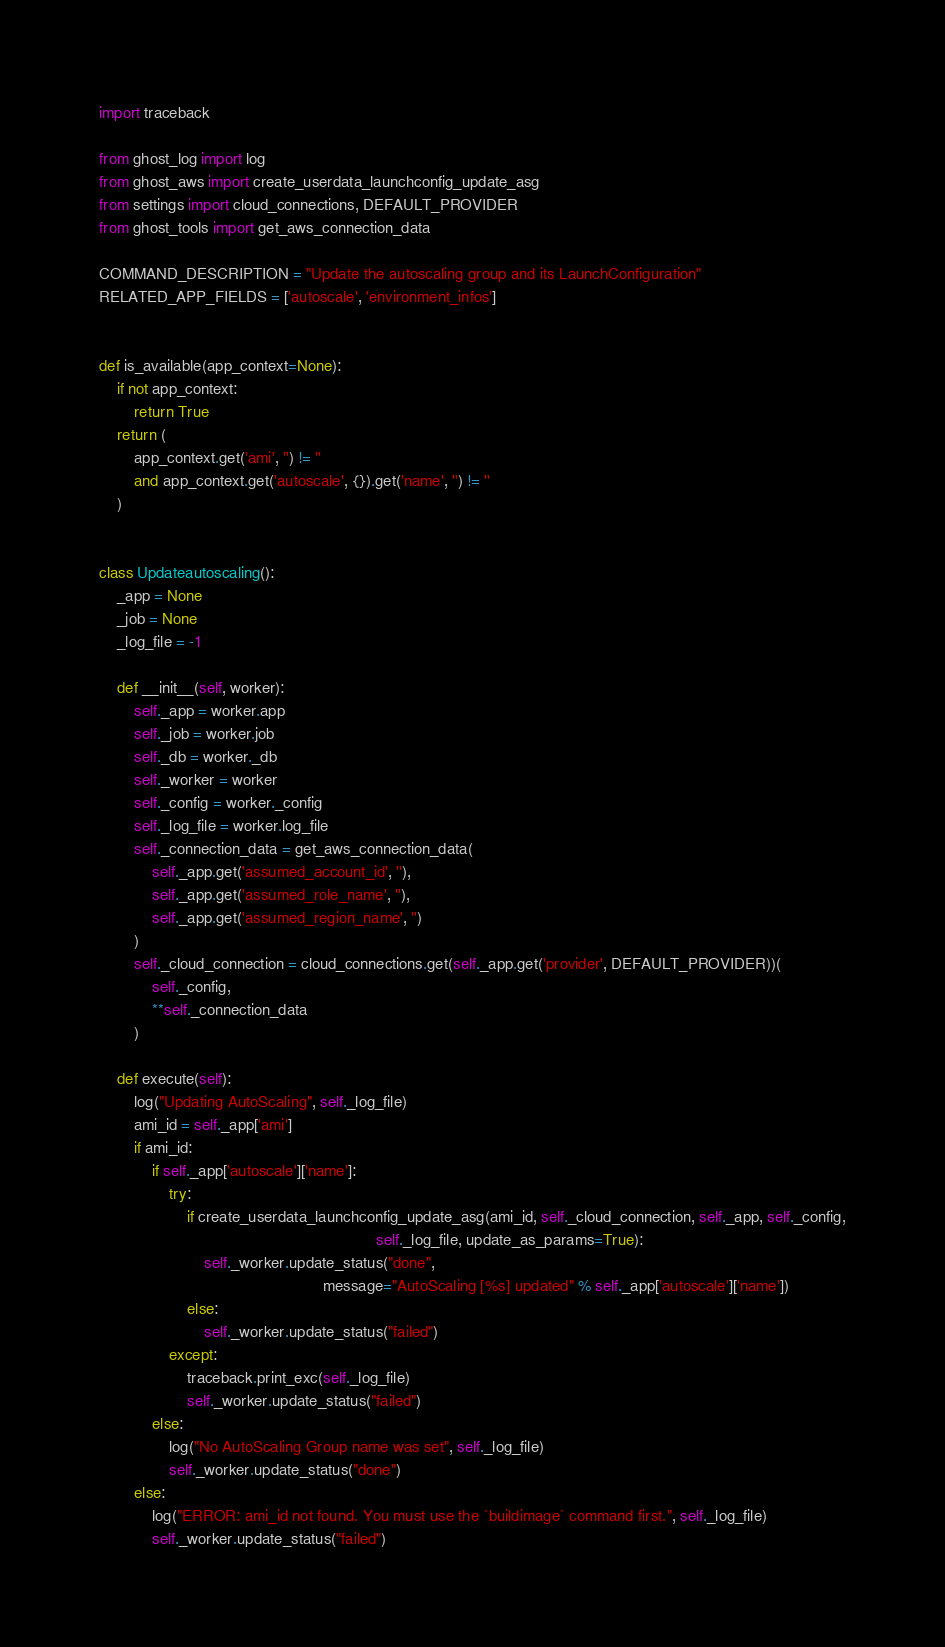<code> <loc_0><loc_0><loc_500><loc_500><_Python_>import traceback

from ghost_log import log
from ghost_aws import create_userdata_launchconfig_update_asg
from settings import cloud_connections, DEFAULT_PROVIDER
from ghost_tools import get_aws_connection_data

COMMAND_DESCRIPTION = "Update the autoscaling group and its LaunchConfiguration"
RELATED_APP_FIELDS = ['autoscale', 'environment_infos']


def is_available(app_context=None):
    if not app_context:
        return True
    return (
        app_context.get('ami', '') != ''
        and app_context.get('autoscale', {}).get('name', '') != ''
    )


class Updateautoscaling():
    _app = None
    _job = None
    _log_file = -1

    def __init__(self, worker):
        self._app = worker.app
        self._job = worker.job
        self._db = worker._db
        self._worker = worker
        self._config = worker._config
        self._log_file = worker.log_file
        self._connection_data = get_aws_connection_data(
            self._app.get('assumed_account_id', ''),
            self._app.get('assumed_role_name', ''),
            self._app.get('assumed_region_name', '')
        )
        self._cloud_connection = cloud_connections.get(self._app.get('provider', DEFAULT_PROVIDER))(
            self._config,
            **self._connection_data
        )

    def execute(self):
        log("Updating AutoScaling", self._log_file)
        ami_id = self._app['ami']
        if ami_id:
            if self._app['autoscale']['name']:
                try:
                    if create_userdata_launchconfig_update_asg(ami_id, self._cloud_connection, self._app, self._config,
                                                               self._log_file, update_as_params=True):
                        self._worker.update_status("done",
                                                   message="AutoScaling [%s] updated" % self._app['autoscale']['name'])
                    else:
                        self._worker.update_status("failed")
                except:
                    traceback.print_exc(self._log_file)
                    self._worker.update_status("failed")
            else:
                log("No AutoScaling Group name was set", self._log_file)
                self._worker.update_status("done")
        else:
            log("ERROR: ami_id not found. You must use the `buildimage` command first.", self._log_file)
            self._worker.update_status("failed")
</code> 